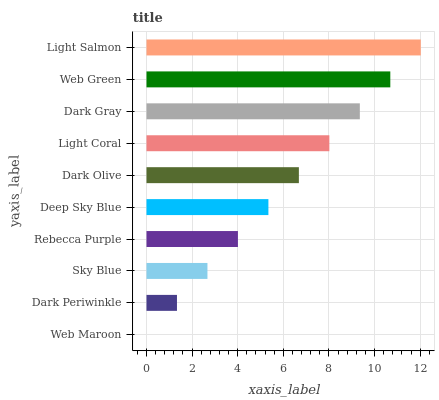Is Web Maroon the minimum?
Answer yes or no. Yes. Is Light Salmon the maximum?
Answer yes or no. Yes. Is Dark Periwinkle the minimum?
Answer yes or no. No. Is Dark Periwinkle the maximum?
Answer yes or no. No. Is Dark Periwinkle greater than Web Maroon?
Answer yes or no. Yes. Is Web Maroon less than Dark Periwinkle?
Answer yes or no. Yes. Is Web Maroon greater than Dark Periwinkle?
Answer yes or no. No. Is Dark Periwinkle less than Web Maroon?
Answer yes or no. No. Is Dark Olive the high median?
Answer yes or no. Yes. Is Deep Sky Blue the low median?
Answer yes or no. Yes. Is Web Green the high median?
Answer yes or no. No. Is Sky Blue the low median?
Answer yes or no. No. 